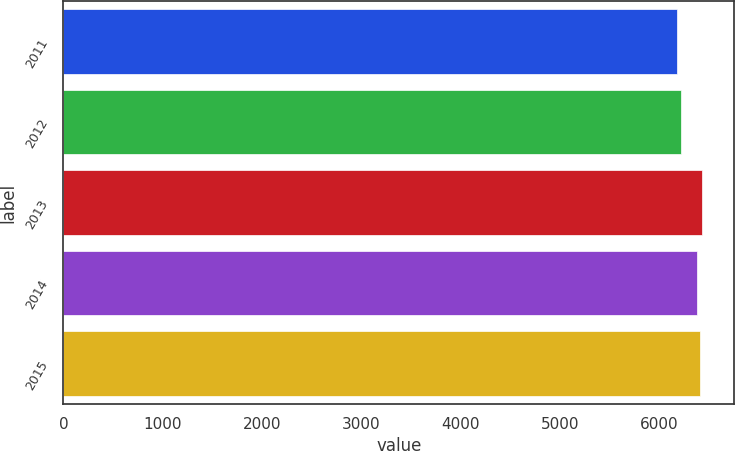Convert chart to OTSL. <chart><loc_0><loc_0><loc_500><loc_500><bar_chart><fcel>2011<fcel>2012<fcel>2013<fcel>2014<fcel>2015<nl><fcel>6178<fcel>6225<fcel>6437.4<fcel>6387<fcel>6412.2<nl></chart> 